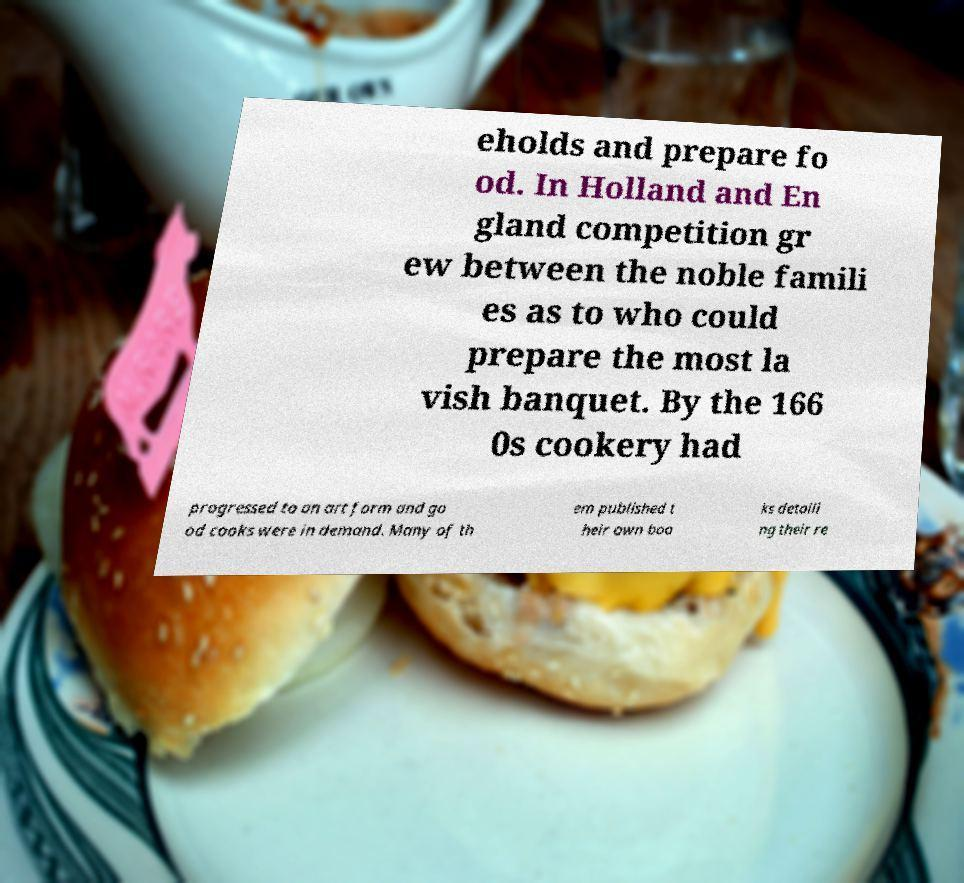Could you extract and type out the text from this image? eholds and prepare fo od. In Holland and En gland competition gr ew between the noble famili es as to who could prepare the most la vish banquet. By the 166 0s cookery had progressed to an art form and go od cooks were in demand. Many of th em published t heir own boo ks detaili ng their re 